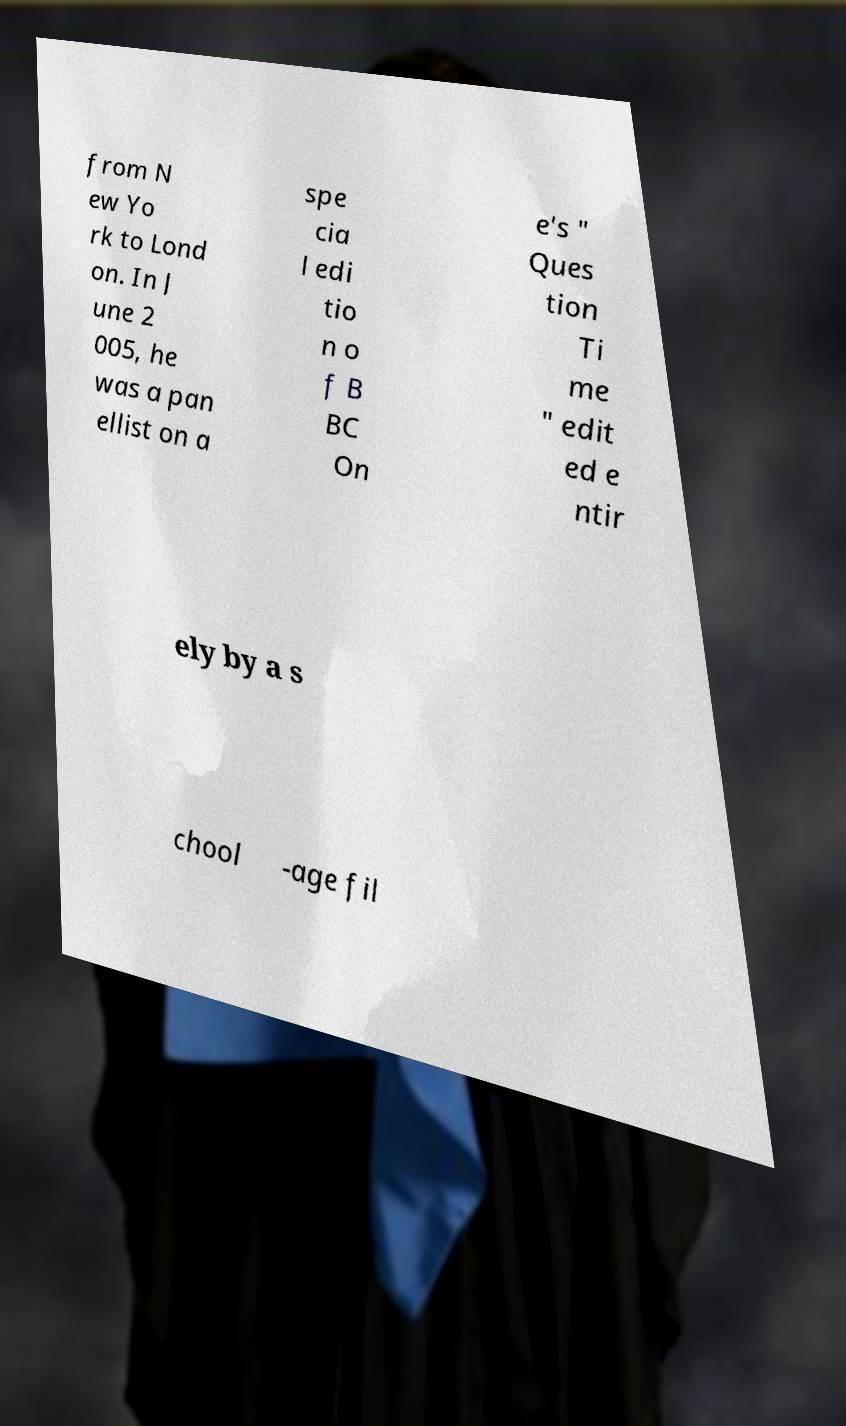There's text embedded in this image that I need extracted. Can you transcribe it verbatim? from N ew Yo rk to Lond on. In J une 2 005, he was a pan ellist on a spe cia l edi tio n o f B BC On e's " Ques tion Ti me " edit ed e ntir ely by a s chool -age fil 